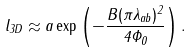<formula> <loc_0><loc_0><loc_500><loc_500>l _ { 3 D } \approx a \exp \left ( - \frac { B ( \pi \lambda _ { a b } ) ^ { 2 } } { 4 \Phi _ { 0 } } \right ) .</formula> 